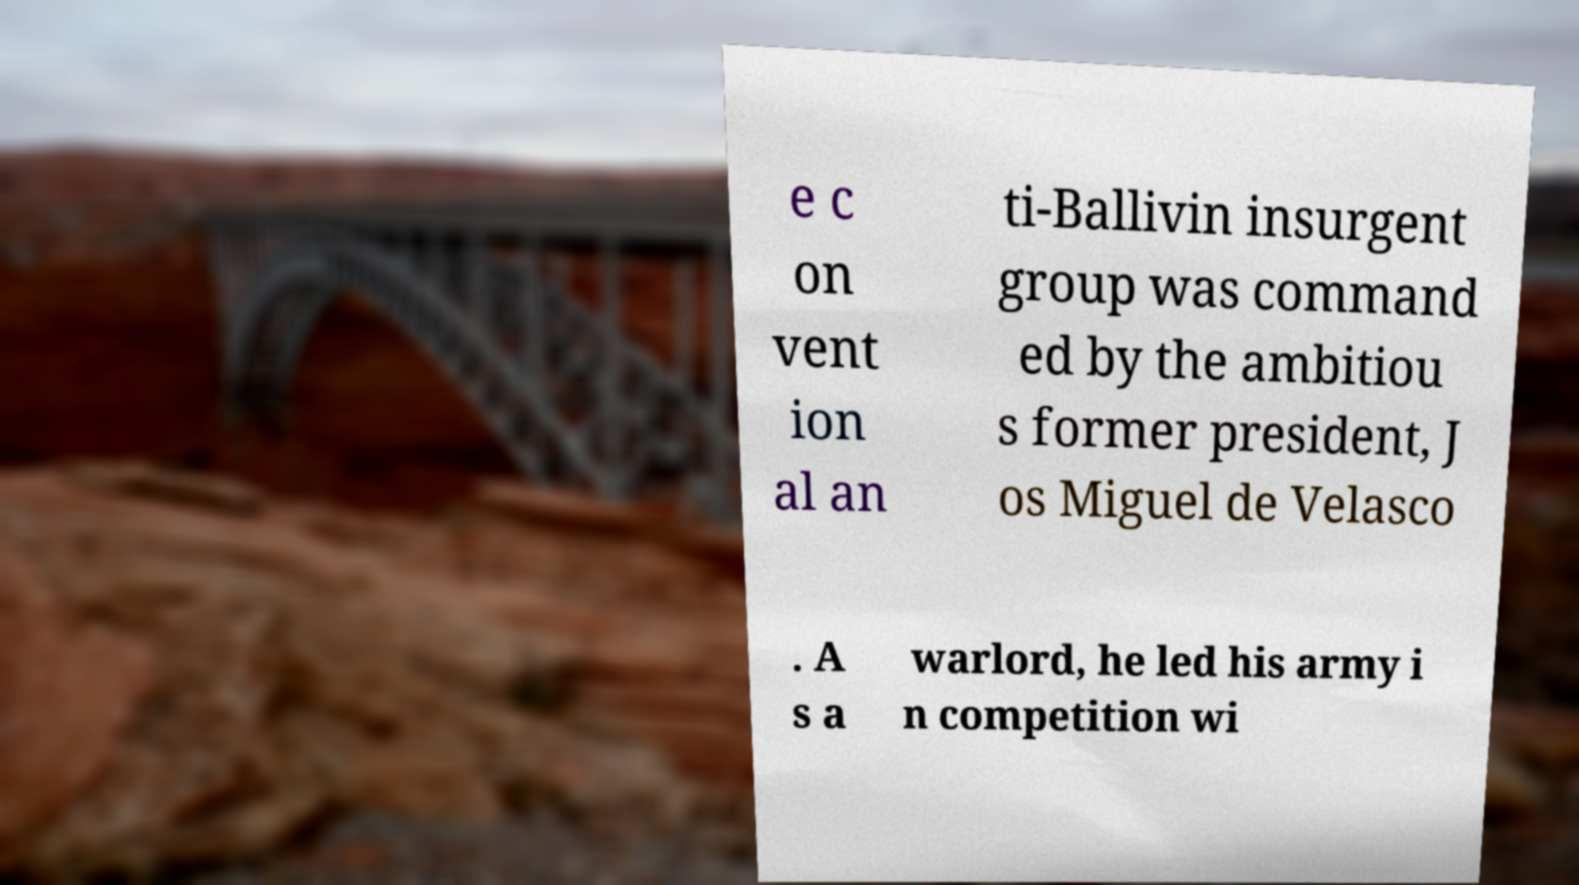I need the written content from this picture converted into text. Can you do that? e c on vent ion al an ti-Ballivin insurgent group was command ed by the ambitiou s former president, J os Miguel de Velasco . A s a warlord, he led his army i n competition wi 